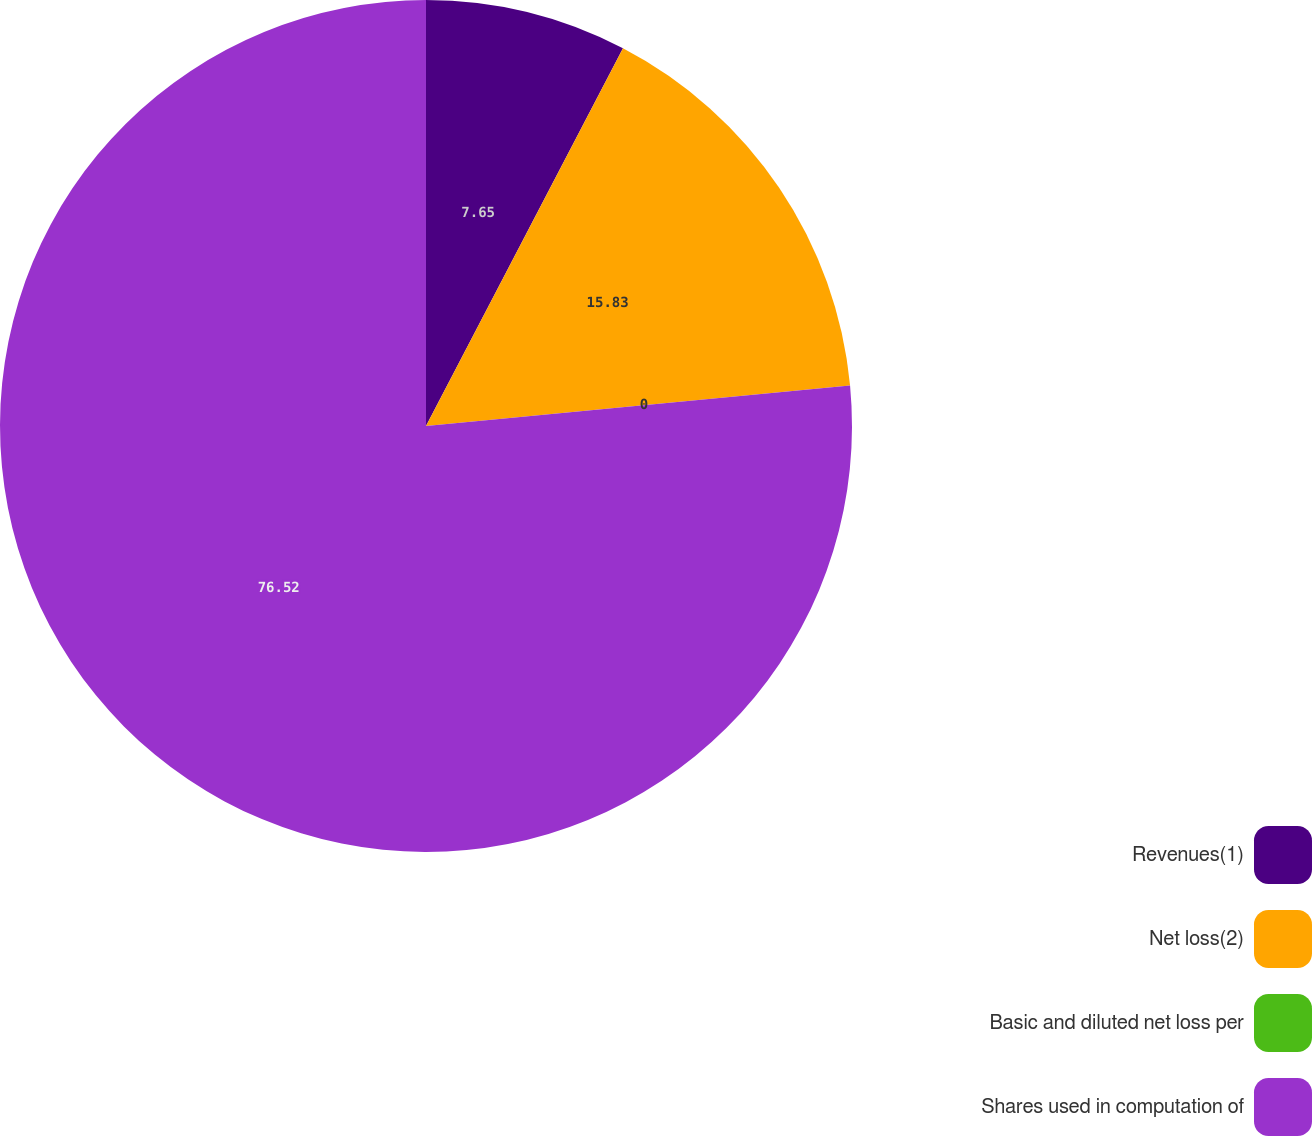Convert chart. <chart><loc_0><loc_0><loc_500><loc_500><pie_chart><fcel>Revenues(1)<fcel>Net loss(2)<fcel>Basic and diluted net loss per<fcel>Shares used in computation of<nl><fcel>7.65%<fcel>15.83%<fcel>0.0%<fcel>76.51%<nl></chart> 